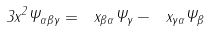<formula> <loc_0><loc_0><loc_500><loc_500>3 x ^ { 2 } \Psi _ { \alpha \beta \gamma } = \ x _ { \beta \alpha } \Psi _ { \gamma } - \ x _ { \gamma \alpha } \Psi _ { \beta }</formula> 